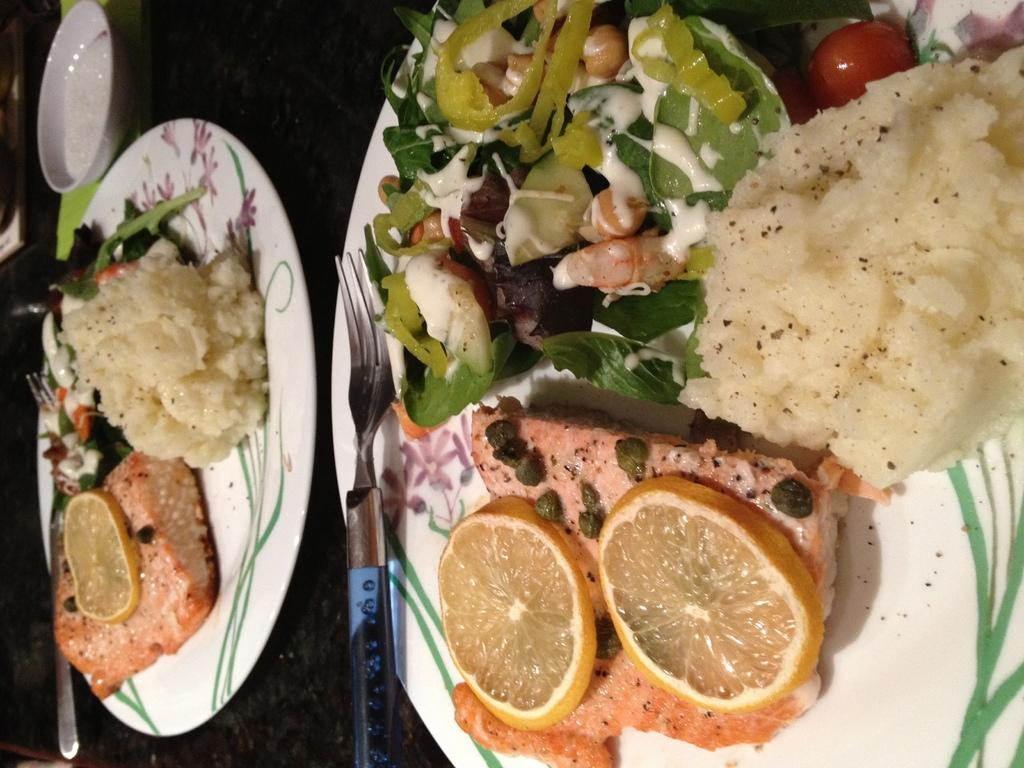What are the people in the image doing? The people in the image are sitting around a table. What are the people holding in the image? The people are holding plates of food. What type of bells can be heard ringing in the image? There are no bells present in the image, and therefore no sound can be heard. 